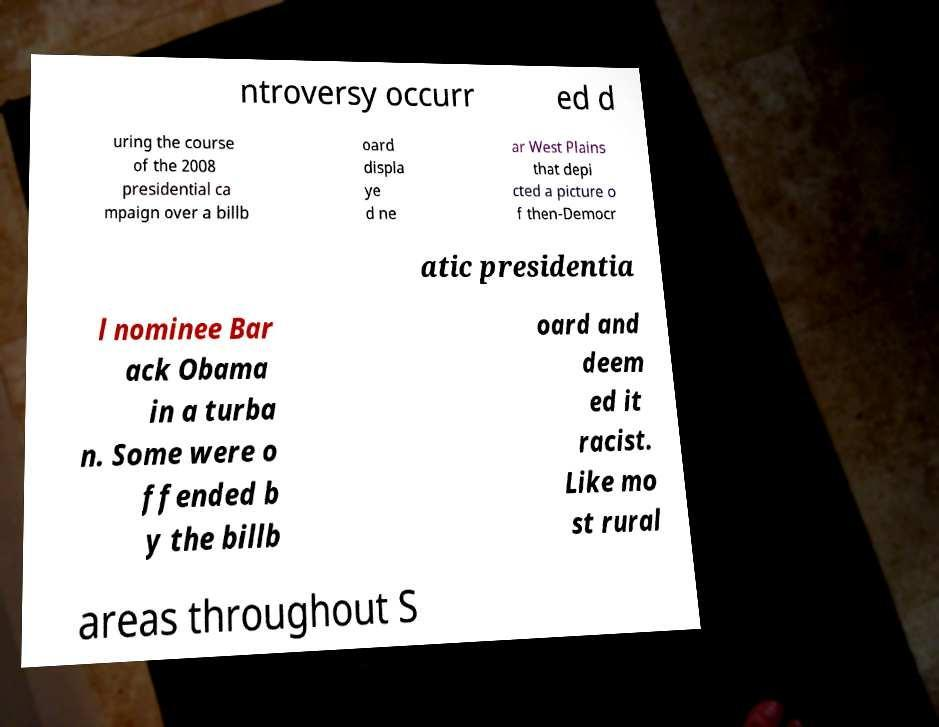Please read and relay the text visible in this image. What does it say? ntroversy occurr ed d uring the course of the 2008 presidential ca mpaign over a billb oard displa ye d ne ar West Plains that depi cted a picture o f then-Democr atic presidentia l nominee Bar ack Obama in a turba n. Some were o ffended b y the billb oard and deem ed it racist. Like mo st rural areas throughout S 